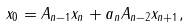<formula> <loc_0><loc_0><loc_500><loc_500>x _ { 0 } = A _ { n - 1 } x _ { n } + a _ { n } A _ { n - 2 } x _ { n + 1 } ,</formula> 